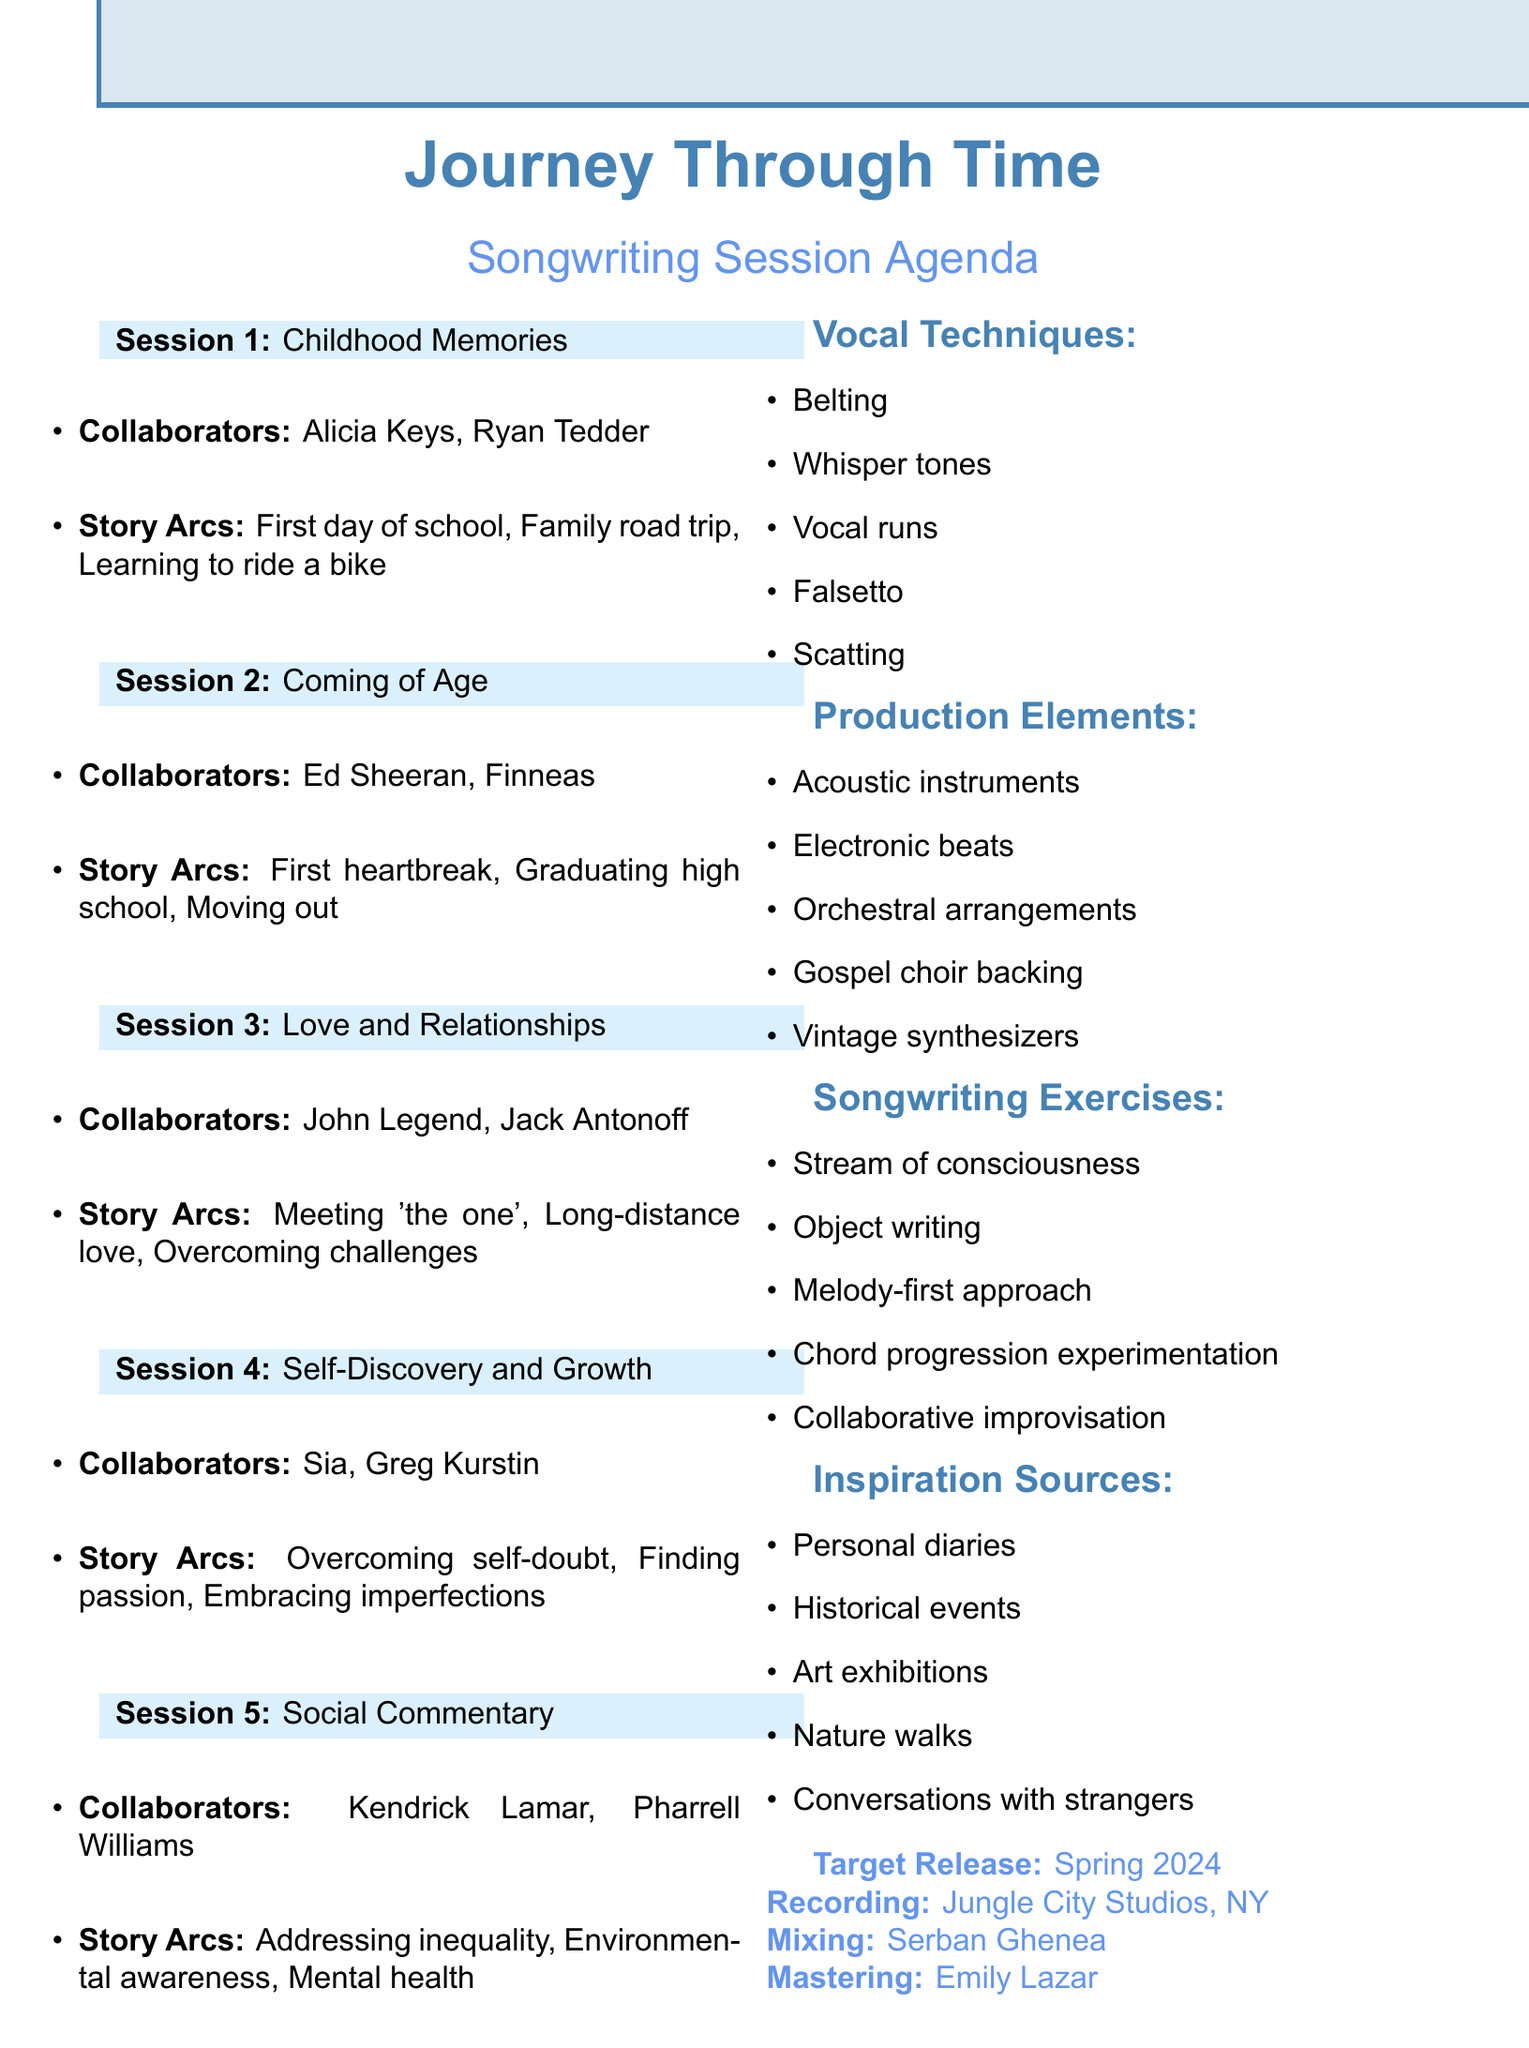What is the album concept? The album concept is the overarching theme or idea that unifies the songs in the album, which in this case is provided in the document as "Journey Through Time."
Answer: Journey Through Time Who is collaborating on the first songwriting session? The document lists the collaborators for the first session; they are Alicia Keys and Ryan Tedder.
Answer: Alicia Keys, Ryan Tedder What is the target release date for the album? The target release date is explicitly stated in the document and refers to when the album is planned to be available to the public.
Answer: Spring 2024 What theme is explored in the third songwriting session? The document indicates the specific theme of each songwriting session, with the third being focused on love.
Answer: Love and Relationships How many songwriting sessions are planned? The document specifies the number of sessions through a count and the list provided.
Answer: 5 Who is the mixing engineer for the album? The document contains information about the personnel involved in the album’s production, naming Serban Ghenea as the mixing engineer.
Answer: Serban Ghenea What vocal technique is listed as the first to explore? The document provides a list of vocal techniques that are planned for exploration, with the first one being a specific style.
Answer: Belting Which theme includes a story arc about overcoming self-doubt? The potential story arcs are linked with specific themes in the document; overcoming self-doubt is one of the arcs listed.
Answer: Self-Discovery and Growth What is one of the inspiration sources mentioned? The document includes a bullet point list of inspiration sources for songwriting; one of them can be identified as a significant contributing factor.
Answer: Personal diaries 